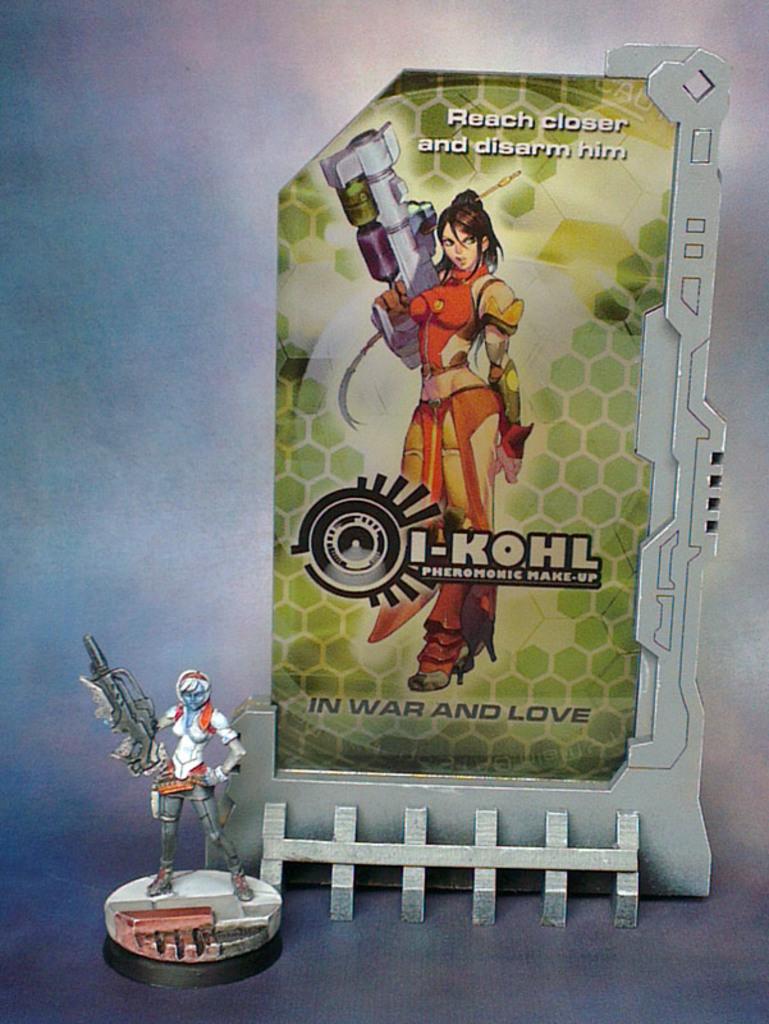What is the title?
Give a very brief answer. I-kohl. 